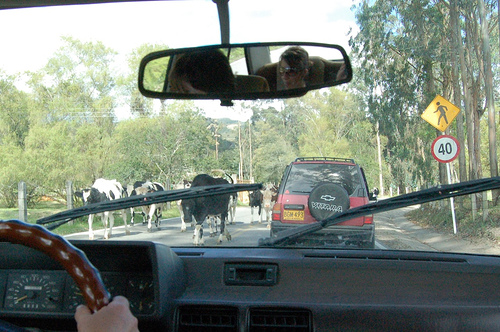Identify the text displayed in this image. 40 